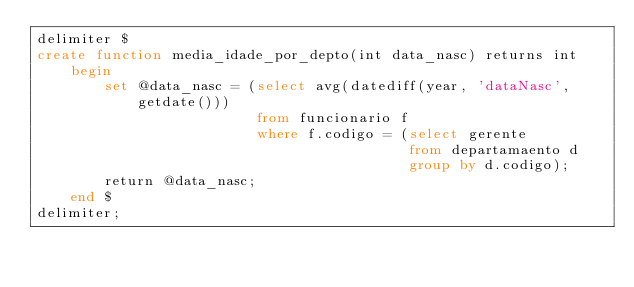<code> <loc_0><loc_0><loc_500><loc_500><_SQL_>delimiter $
create function media_idade_por_depto(int data_nasc) returns int
	begin
		set @data_nasc = (select avg(datediff(year, 'dataNasc', getdate()))
						  from funcionario f 
                          where f.codigo = (select gerente
											from departamaento d 
                                            group by d.codigo);
		return @data_nasc;
	end $
delimiter;
</code> 